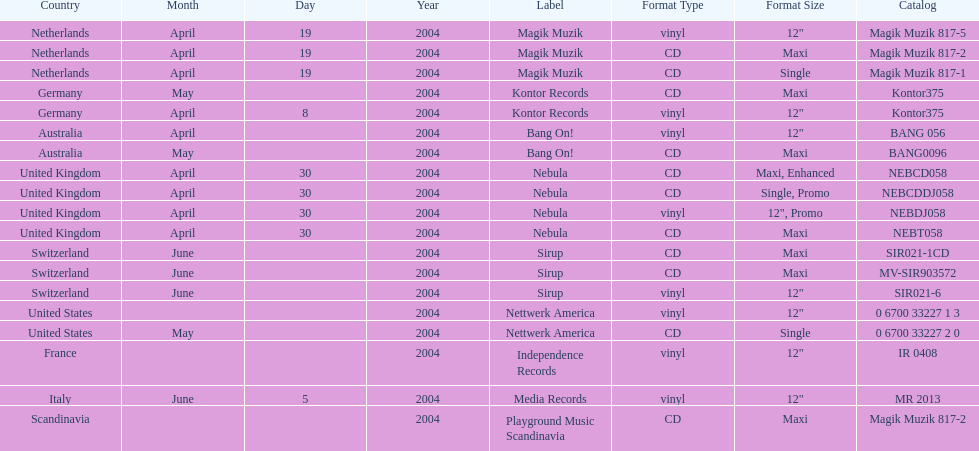What region is listed at the top? Netherlands. 